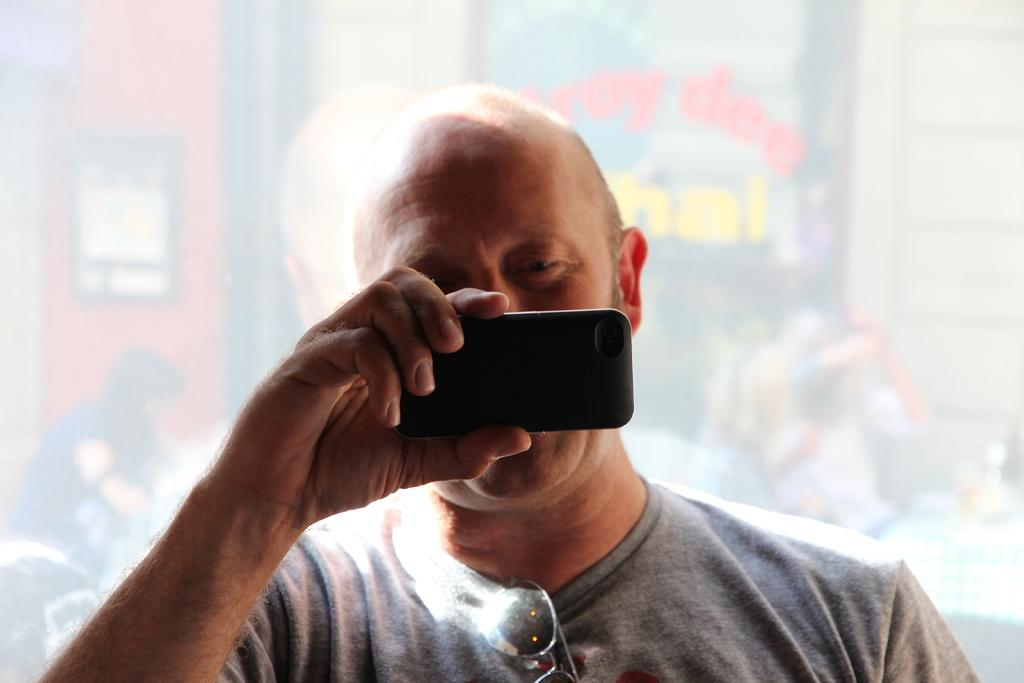Who is present in the image? There is a man in the image. What is the man holding in the image? The man is holding a phone. What can be seen in the background of the image? There is a building in the background of the image. What type of kite is the man flying in the image? There is no kite present in the image; the man is holding a phone. How many socks can be seen on the man's feet in the image? The image does not show the man's feet, so it is not possible to determine if he is wearing socks or not. 